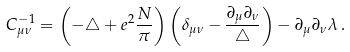Convert formula to latex. <formula><loc_0><loc_0><loc_500><loc_500>C ^ { - 1 } _ { \mu \nu } = \left ( - \triangle + e ^ { 2 } \frac { N } { \pi } \right ) \left ( \delta _ { \mu \nu } - \frac { \partial _ { \mu } \partial _ { \nu } } { \triangle } \right ) - \partial _ { \mu } \partial _ { \nu } \lambda \, .</formula> 